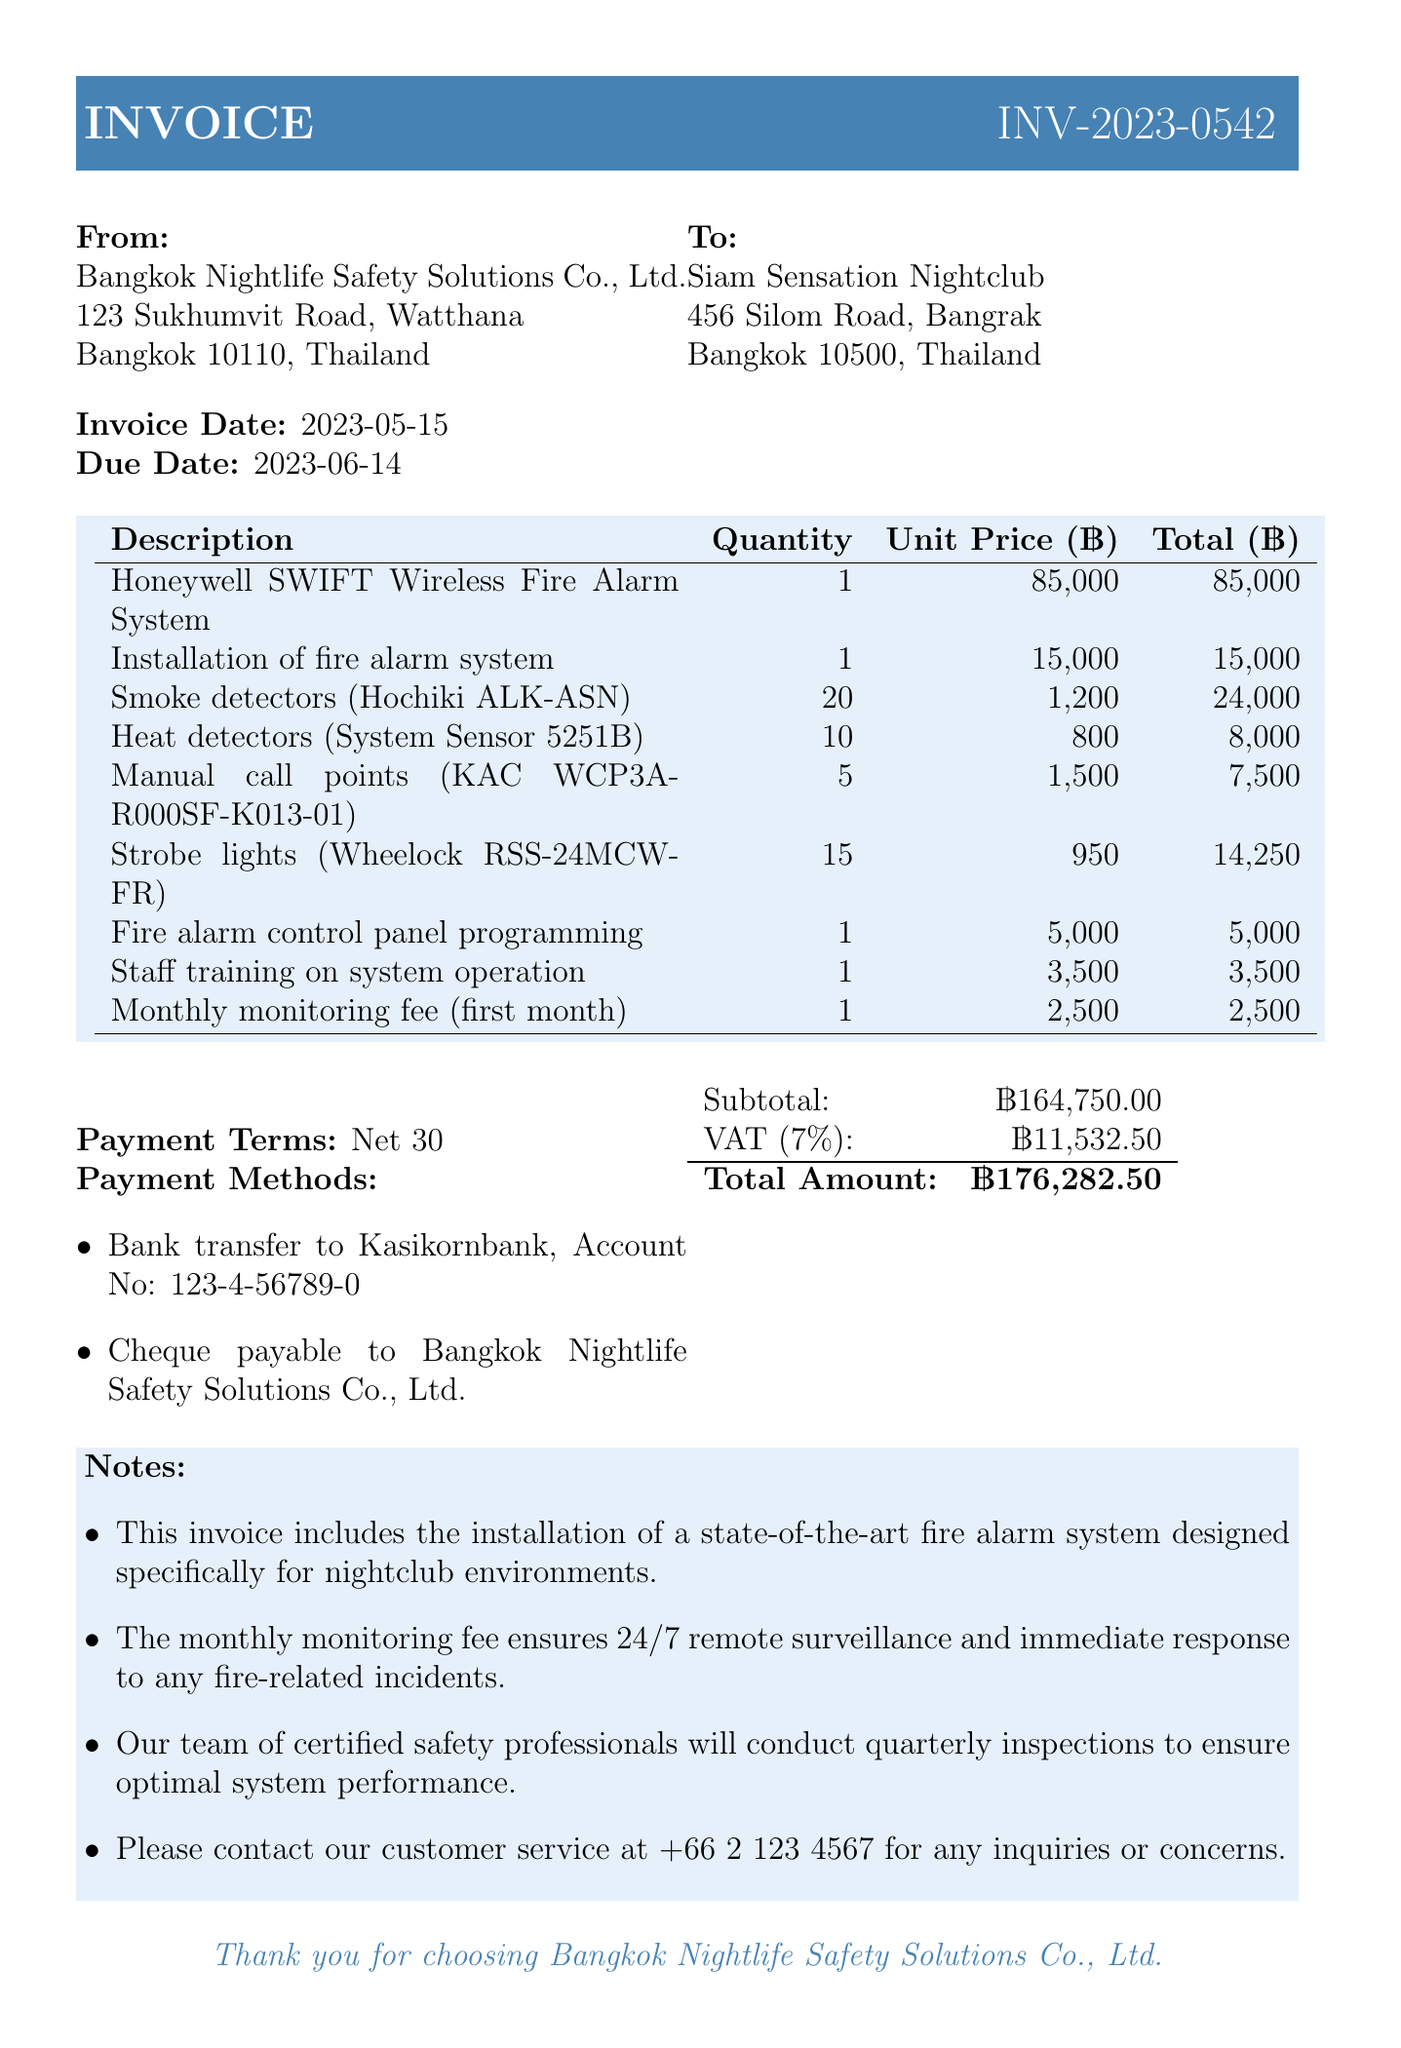what is the invoice number? The invoice number is clearly stated in the document for reference.
Answer: INV-2023-0542 who is the customer? The customer name is listed prominently in the document.
Answer: Siam Sensation Nightclub what is the total amount due? The total amount due is calculated at the end of the invoice summary.
Answer: 176,282.50 what is the VAT rate applied? The VAT rate is explicitly mentioned in the invoice summary section.
Answer: 7% when is the payment due? The due date is prominently displayed next to the invoice date.
Answer: 2023-06-14 what equipment is included for smoke detection? The document lists specific equipment types for smoke detection purposes.
Answer: Hochiki ALK-ASN how many heat detectors are provided? The quantity of heat detectors is listed with the description.
Answer: 10 what is included in the monthly monitoring fee? The document notes the purpose of the monthly monitoring fee provided.
Answer: 24/7 remote surveillance what payment methods are available? The payment methods are outlined clearly in the invoice's payment terms section.
Answer: Bank transfer and cheque 